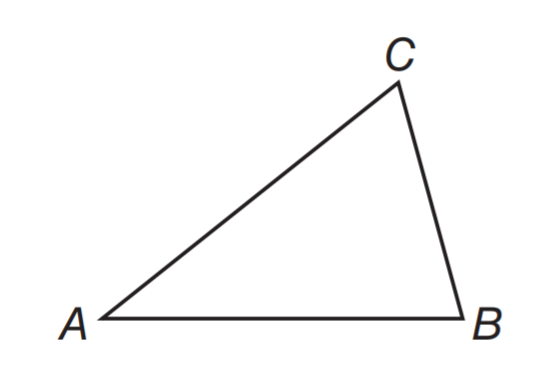Question: m \angle B = 76. The measure of \angle A is half the measure of \angle B. What is m \angle C?
Choices:
A. 46
B. 56
C. 66
D. 76
Answer with the letter. Answer: C 